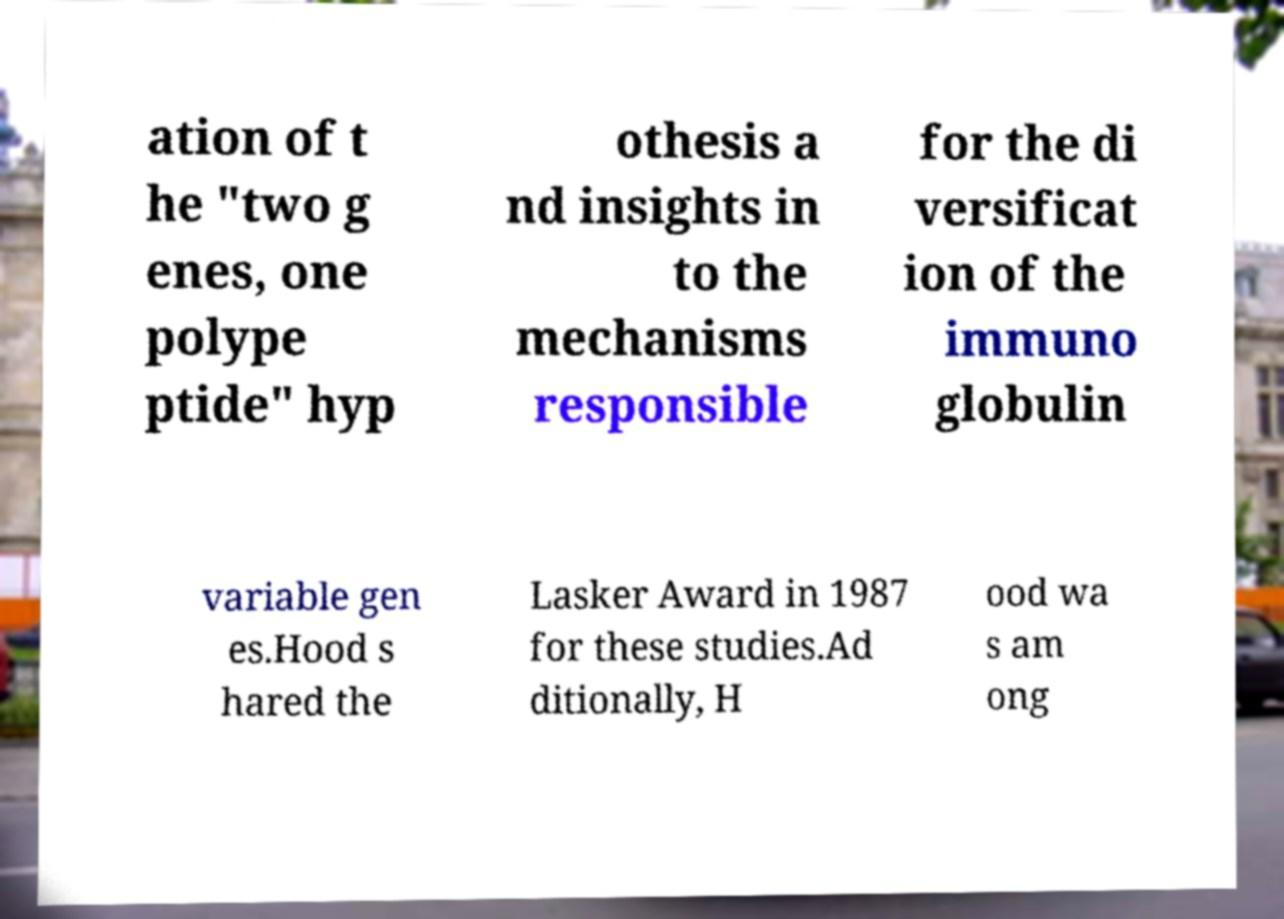I need the written content from this picture converted into text. Can you do that? ation of t he "two g enes, one polype ptide" hyp othesis a nd insights in to the mechanisms responsible for the di versificat ion of the immuno globulin variable gen es.Hood s hared the Lasker Award in 1987 for these studies.Ad ditionally, H ood wa s am ong 